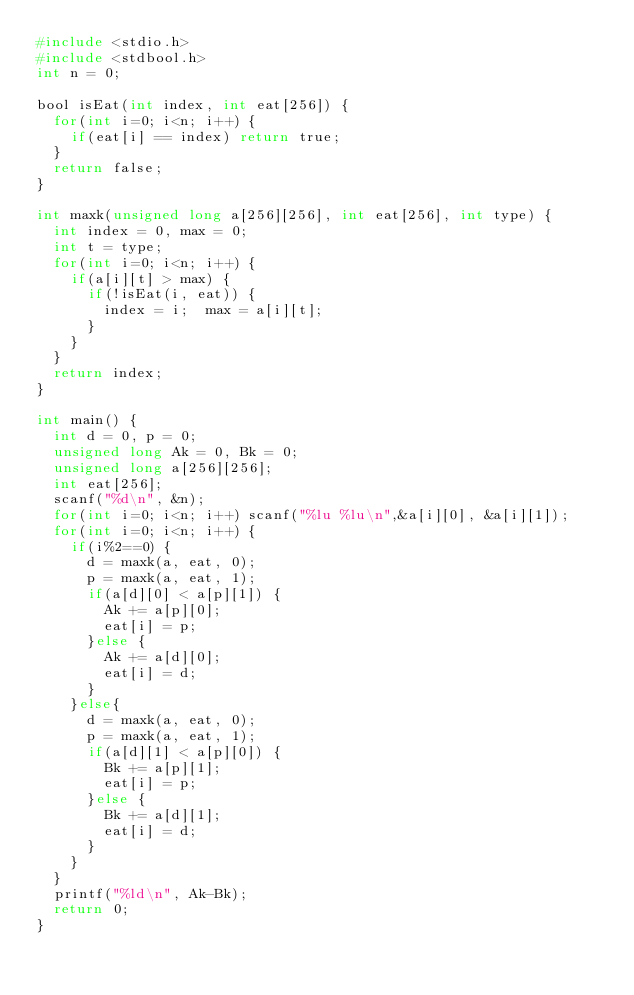Convert code to text. <code><loc_0><loc_0><loc_500><loc_500><_C_>#include <stdio.h>
#include <stdbool.h>
int n = 0;

bool isEat(int index, int eat[256]) {
  for(int i=0; i<n; i++) {
    if(eat[i] == index) return true;
  }
  return false;
}

int maxk(unsigned long a[256][256], int eat[256], int type) {
  int index = 0, max = 0;
  int t = type;
  for(int i=0; i<n; i++) {
    if(a[i][t] > max) {
      if(!isEat(i, eat)) {
        index = i;  max = a[i][t];
      }
    }
  }
  return index;
}

int main() {
  int d = 0, p = 0;
  unsigned long Ak = 0, Bk = 0;
  unsigned long a[256][256];
  int eat[256];
  scanf("%d\n", &n);
  for(int i=0; i<n; i++) scanf("%lu %lu\n",&a[i][0], &a[i][1]);
  for(int i=0; i<n; i++) {
    if(i%2==0) {
      d = maxk(a, eat, 0);
      p = maxk(a, eat, 1);
      if(a[d][0] < a[p][1]) {
        Ak += a[p][0];
        eat[i] = p;
      }else {
        Ak += a[d][0];
        eat[i] = d;
      }
    }else{
      d = maxk(a, eat, 0);
      p = maxk(a, eat, 1);
      if(a[d][1] < a[p][0]) {
        Bk += a[p][1];
        eat[i] = p;
      }else {
        Bk += a[d][1];
        eat[i] = d;
      }
    }
  }
  printf("%ld\n", Ak-Bk);
  return 0;
}</code> 